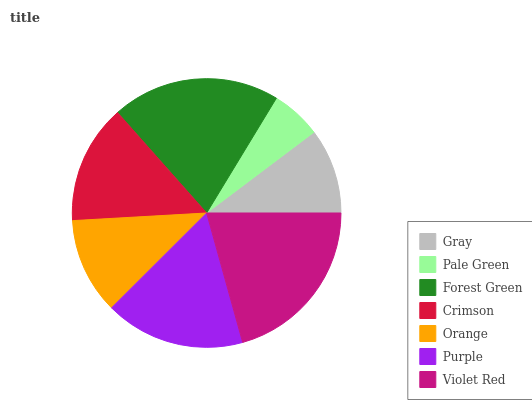Is Pale Green the minimum?
Answer yes or no. Yes. Is Violet Red the maximum?
Answer yes or no. Yes. Is Forest Green the minimum?
Answer yes or no. No. Is Forest Green the maximum?
Answer yes or no. No. Is Forest Green greater than Pale Green?
Answer yes or no. Yes. Is Pale Green less than Forest Green?
Answer yes or no. Yes. Is Pale Green greater than Forest Green?
Answer yes or no. No. Is Forest Green less than Pale Green?
Answer yes or no. No. Is Crimson the high median?
Answer yes or no. Yes. Is Crimson the low median?
Answer yes or no. Yes. Is Violet Red the high median?
Answer yes or no. No. Is Forest Green the low median?
Answer yes or no. No. 